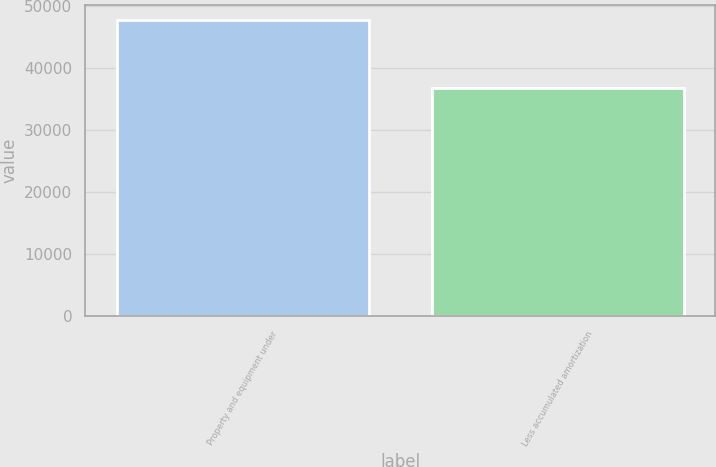Convert chart to OTSL. <chart><loc_0><loc_0><loc_500><loc_500><bar_chart><fcel>Property and equipment under<fcel>Less accumulated amortization<nl><fcel>47842<fcel>36740<nl></chart> 